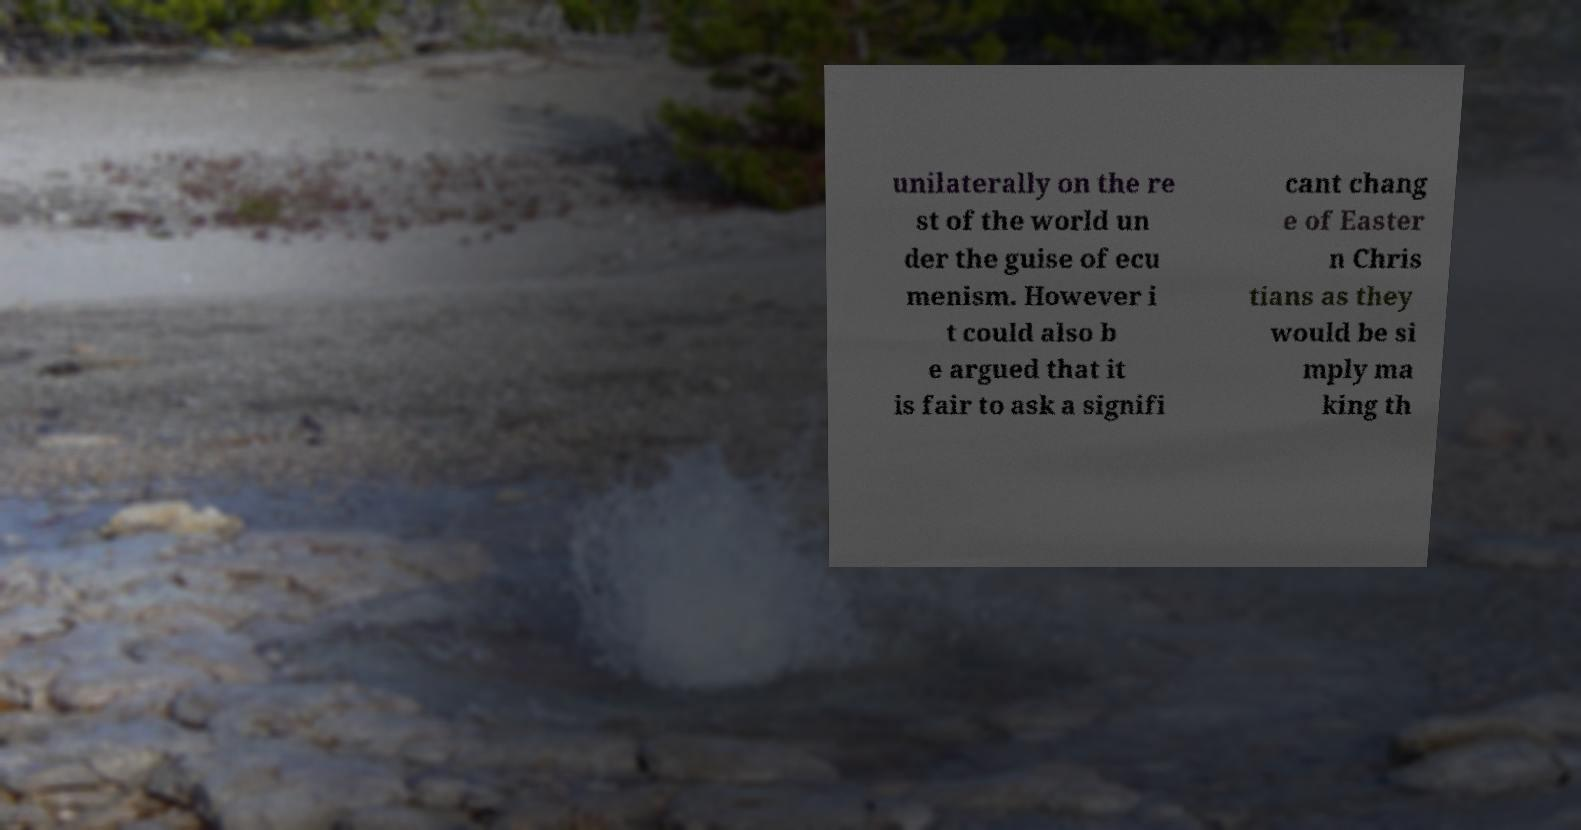What messages or text are displayed in this image? I need them in a readable, typed format. unilaterally on the re st of the world un der the guise of ecu menism. However i t could also b e argued that it is fair to ask a signifi cant chang e of Easter n Chris tians as they would be si mply ma king th 